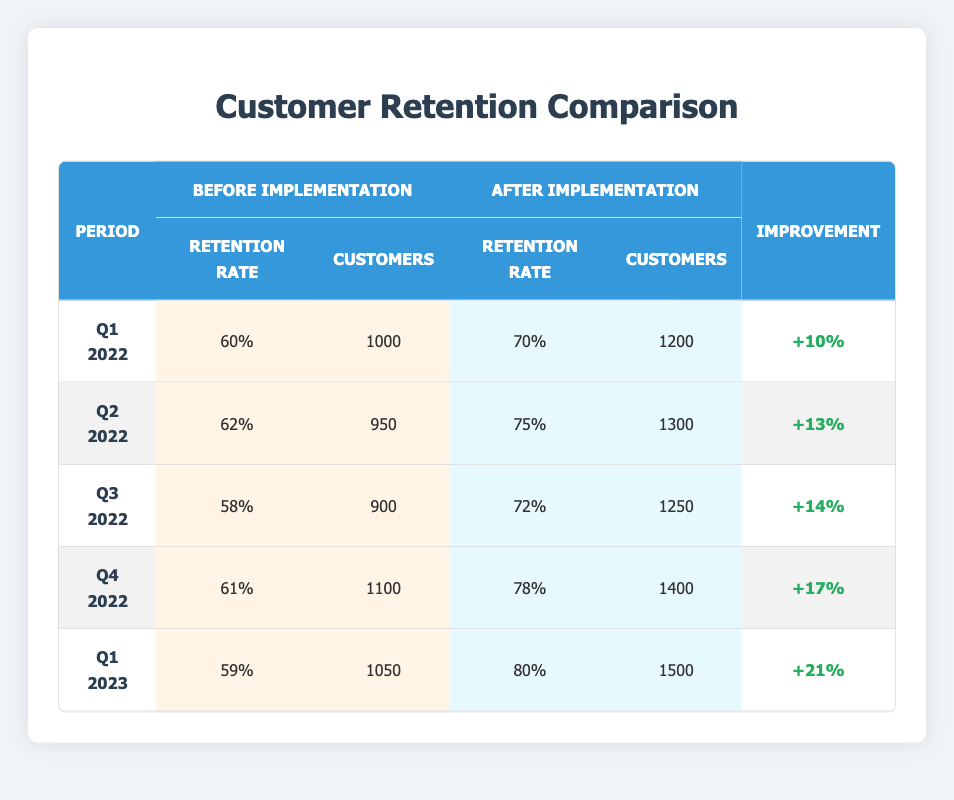What was the retention rate in Q2 2022 before the implementation? The retention rate in Q2 2022 before the implementation is explicitly listed in the table under the "Before Implementation" section for that period. It shows a retention rate of 62%.
Answer: 62 What improvement in retention rate was observed in Q4 2022? The improvement in retention rate can be calculated by subtracting the retention rate before implementation (61%) from the retention rate after implementation (78%). This results in an improvement of 17%.
Answer: 17% Did the number of customers increase after the implementation of the new service in Q1 2023? By comparing the number of customers before (1050) and after (1500) implementation in Q1 2023, we can see that the number of customers did indeed increase.
Answer: Yes What was the average retention rate after implementation over all periods? To find the average retention rate after implementation, we add the retention rates after implementation for each quarter (70 + 75 + 72 + 78 + 80 = 375) and divide by the number of quarters (5), resulting in an average of 75%.
Answer: 75 In which quarter was the highest improvement in retention rate observed? By looking at the "Improvement" column, Q1 2023 shows an improvement of 21%, which is the highest among all quarters listed.
Answer: Q1 2023 Was the retention rate after implementation greater than 75% in Q3 2022? The retention rate after implementation for Q3 2022 is 72%, which is less than 75%. Therefore, this statement is false.
Answer: No How many customers were retained after implementation in Q1 2022? The number of customers retained after implementation for Q1 2022 can be found directly in the table, which states that 1200 customers were retained in that quarter.
Answer: 1200 Which quarter had the lowest retention rate before implementation? Comparing all the "Before Implementation" retention rates in the table, Q3 2022 has the lowest retention rate at 58%.
Answer: Q3 2022 What is the total number of customers retained after implementation across all quarters? To find the total, we add the number of customers after implementation for all quarters (1200 + 1300 + 1250 + 1400 + 1500 = 6000). This indicates the total number of customers retained across all quarters.
Answer: 6000 